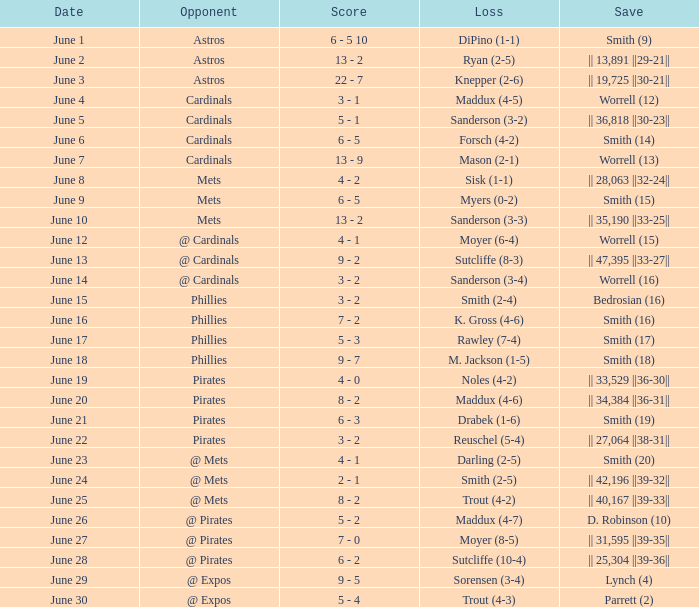The game with a loss of smith (2-4) ended with what score? 3 - 2. 